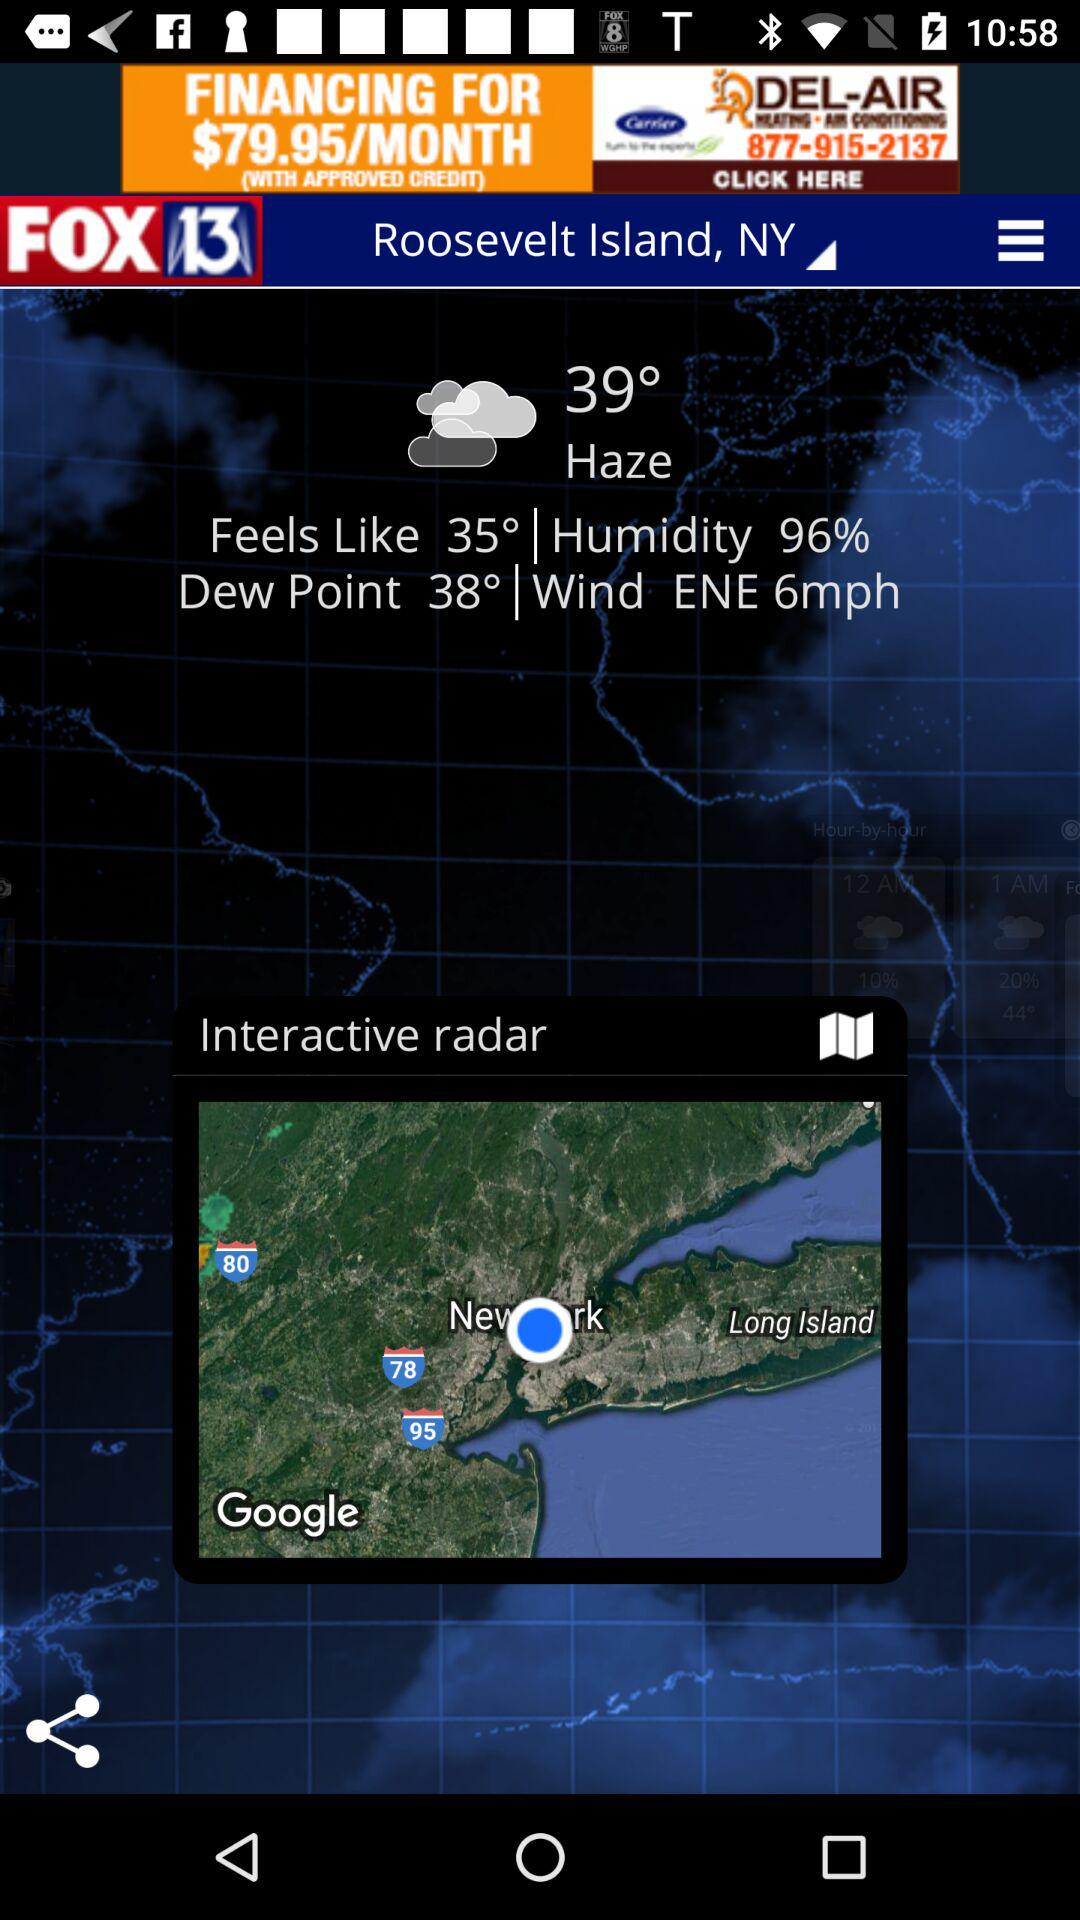How many more degrees Fahrenheit is the current temperature than the feels like temperature?
Answer the question using a single word or phrase. 4 